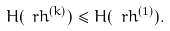Convert formula to latex. <formula><loc_0><loc_0><loc_500><loc_500>H ( \ r h ^ { ( k ) } ) \leq H ( \ r h ^ { ( 1 ) } ) .</formula> 